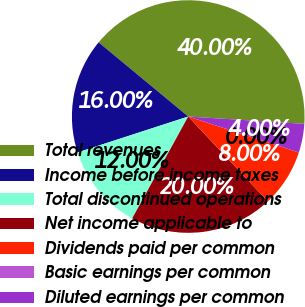<chart> <loc_0><loc_0><loc_500><loc_500><pie_chart><fcel>Total revenues<fcel>Income before income taxes<fcel>Total discontinued operations<fcel>Net income applicable to<fcel>Dividends paid per common<fcel>Basic earnings per common<fcel>Diluted earnings per common<nl><fcel>40.0%<fcel>16.0%<fcel>12.0%<fcel>20.0%<fcel>8.0%<fcel>0.0%<fcel>4.0%<nl></chart> 